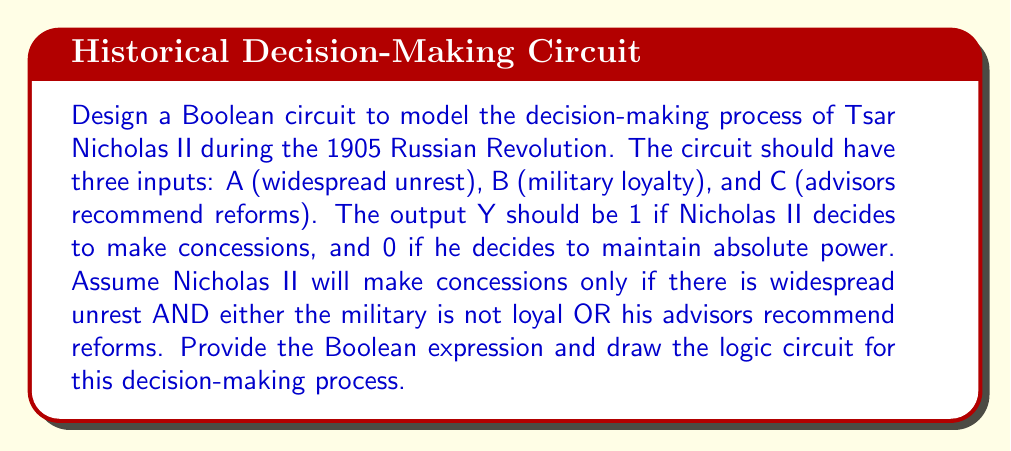Can you answer this question? To model Tsar Nicholas II's decision-making process, we need to follow these steps:

1. Identify the inputs and their meanings:
   A: Widespread unrest (1 if present, 0 if not)
   B: Military loyalty (1 if loyal, 0 if not)
   C: Advisors recommend reforms (1 if yes, 0 if no)

2. Determine the logical conditions for making concessions:
   - There must be widespread unrest (A = 1)
   - AND either:
     - The military is not loyal (B = 0)
     - OR advisors recommend reforms (C = 1)

3. Translate this into a Boolean expression:
   Y = A AND (NOT B OR C)

4. Convert the Boolean expression to its canonical form:
   Y = A * (B' + C)

5. Design the logic circuit based on this expression:
   - Use an AND gate for the main operation
   - Use a NOT gate to invert B
   - Use an OR gate to combine B' and C

6. Draw the logic circuit:

[asy]
import geometry;

pair A = (0,80), B = (0,50), C = (0,20);
pair notB = (50,50), orBC = (100,35), andA = (150,57.5);
pair Y = (200,57.5);

draw(A--(-10,80)--(-10,90));
draw(B--(-10,50)--(-10,60));
draw(C--(-10,20)--(-10,30));

draw(Circle(notB,10));
draw(B--(notB-10,50));
draw((notB+10,50)--(orBC-20,50));

draw(((0,0)--(40,0)--(40,70)--(0,70)--cycle), (20,35));
draw(((100,22.5)--(140,22.5)--(140,92.5)--(100,92.5)--cycle), (120,57.5));

draw(C--(orBC-20,20));
draw((orBC+20,35)--(andA-20,35));
draw(A--(andA-20,80));
draw((andA+20,57.5)--Y);

label("A", A, W);
label("B", B, W);
label("C", C, W);
label("Y", Y, E);

label("NOT", notB, N);
label("OR", (20,35));
label("AND", (120,57.5));
[/asy]

This circuit accurately represents the decision-making process of Tsar Nicholas II based on the given conditions.
Answer: Y = A * (B' + C) 